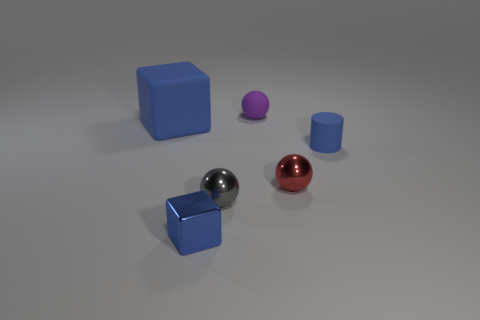Does the blue rubber cube have the same size as the blue rubber thing that is to the right of the tiny blue block?
Make the answer very short. No. What number of things are red balls or small red metallic cylinders?
Ensure brevity in your answer.  1. What number of other objects are there of the same size as the red sphere?
Provide a succinct answer. 4. Do the tiny cylinder and the metallic ball that is on the left side of the rubber sphere have the same color?
Your response must be concise. No. What number of cylinders are big blue objects or tiny blue things?
Offer a terse response. 1. Is there any other thing that is the same color as the large matte cube?
Your response must be concise. Yes. There is a blue cube that is in front of the small metal ball that is left of the purple rubber ball; what is it made of?
Give a very brief answer. Metal. Do the gray object and the small red ball that is on the right side of the tiny purple thing have the same material?
Ensure brevity in your answer.  Yes. What number of objects are tiny spheres in front of the large blue rubber block or large brown matte cylinders?
Provide a succinct answer. 2. Is there a rubber thing of the same color as the tiny rubber ball?
Keep it short and to the point. No. 